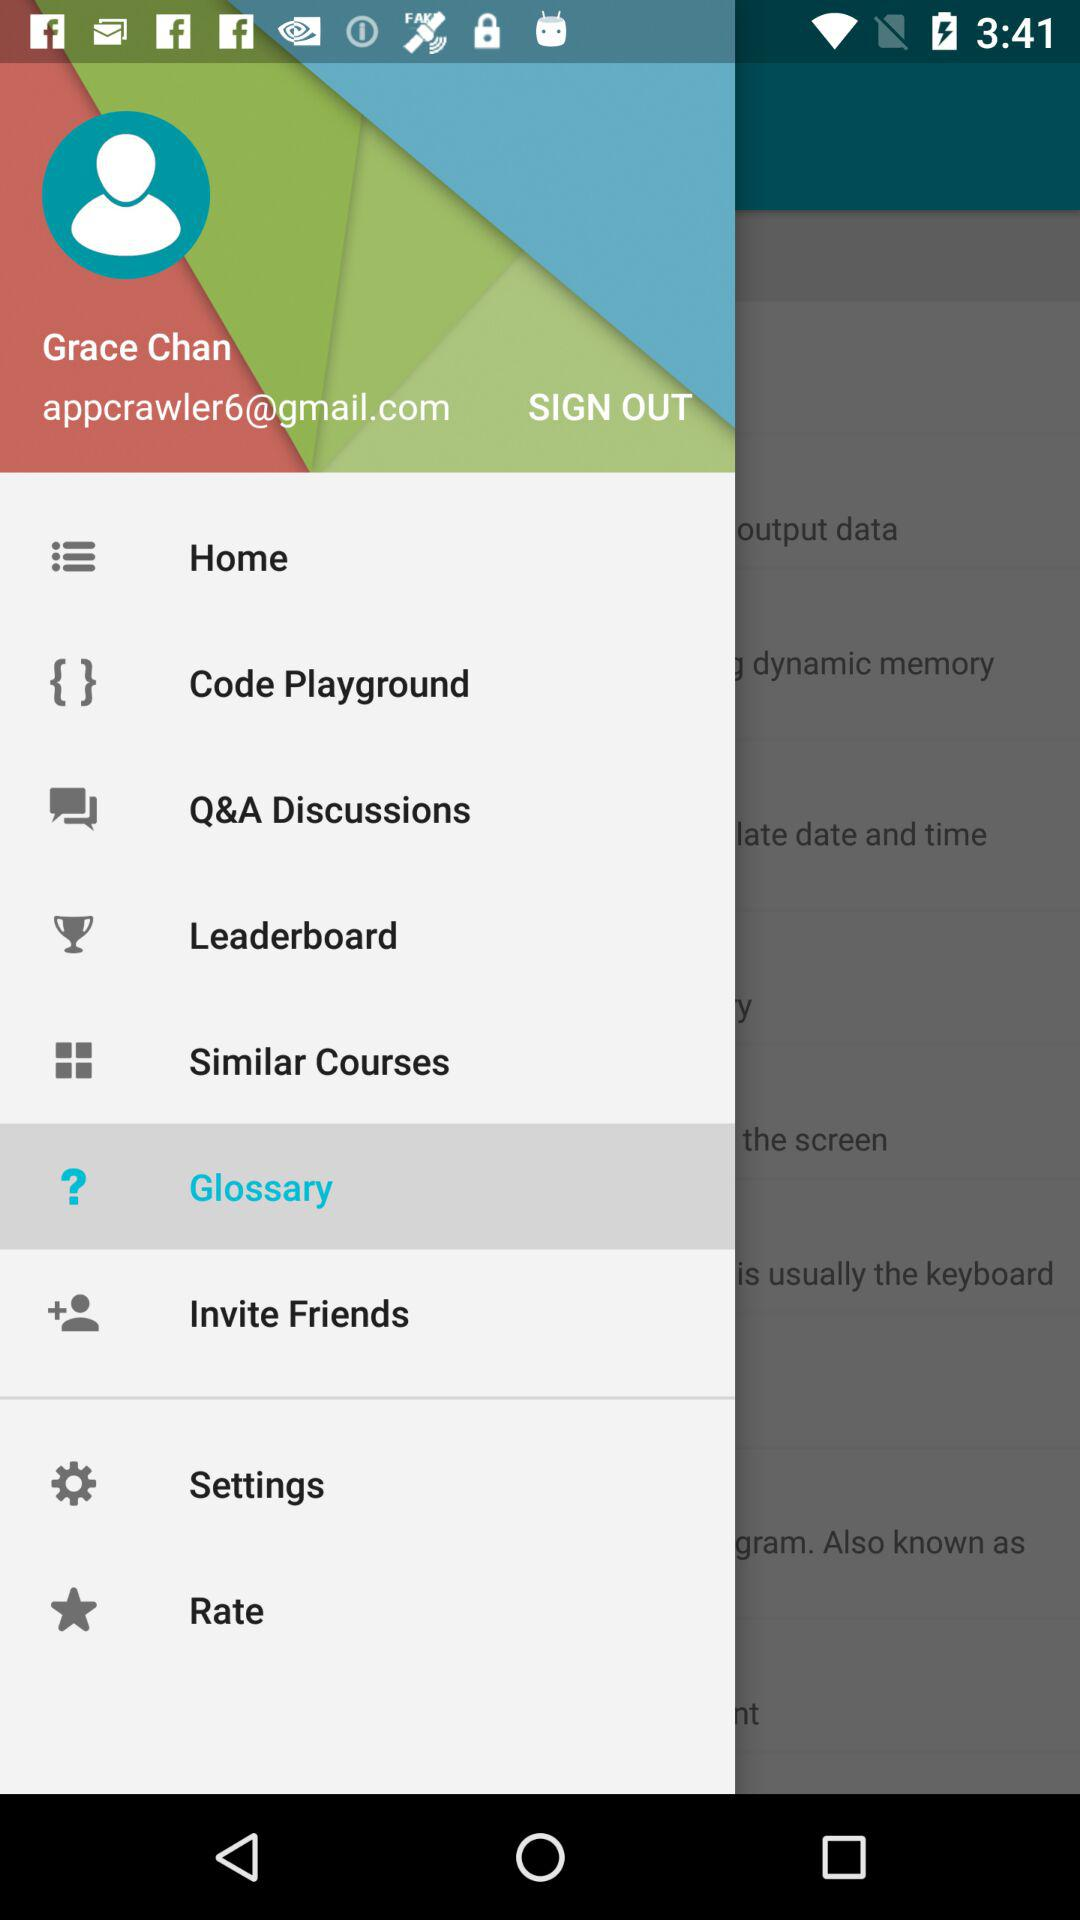What is the login name? The login name is Grace Chan. 